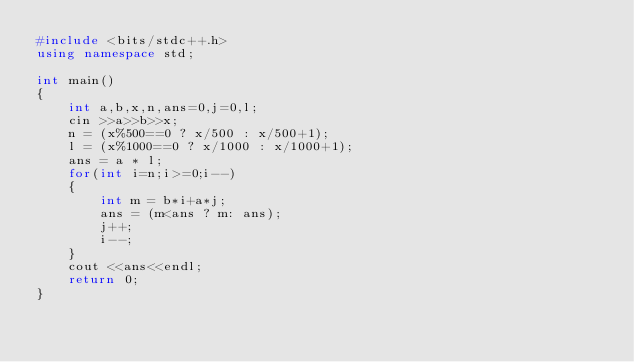Convert code to text. <code><loc_0><loc_0><loc_500><loc_500><_C++_>#include <bits/stdc++.h>
using namespace std;

int main()
{
    int a,b,x,n,ans=0,j=0,l;
    cin >>a>>b>>x;
    n = (x%500==0 ? x/500 : x/500+1);
    l = (x%1000==0 ? x/1000 : x/1000+1);
    ans = a * l;
    for(int i=n;i>=0;i--)
    {
        int m = b*i+a*j;
        ans = (m<ans ? m: ans);
        j++;
        i--;
    }
    cout <<ans<<endl;
    return 0;
}
</code> 